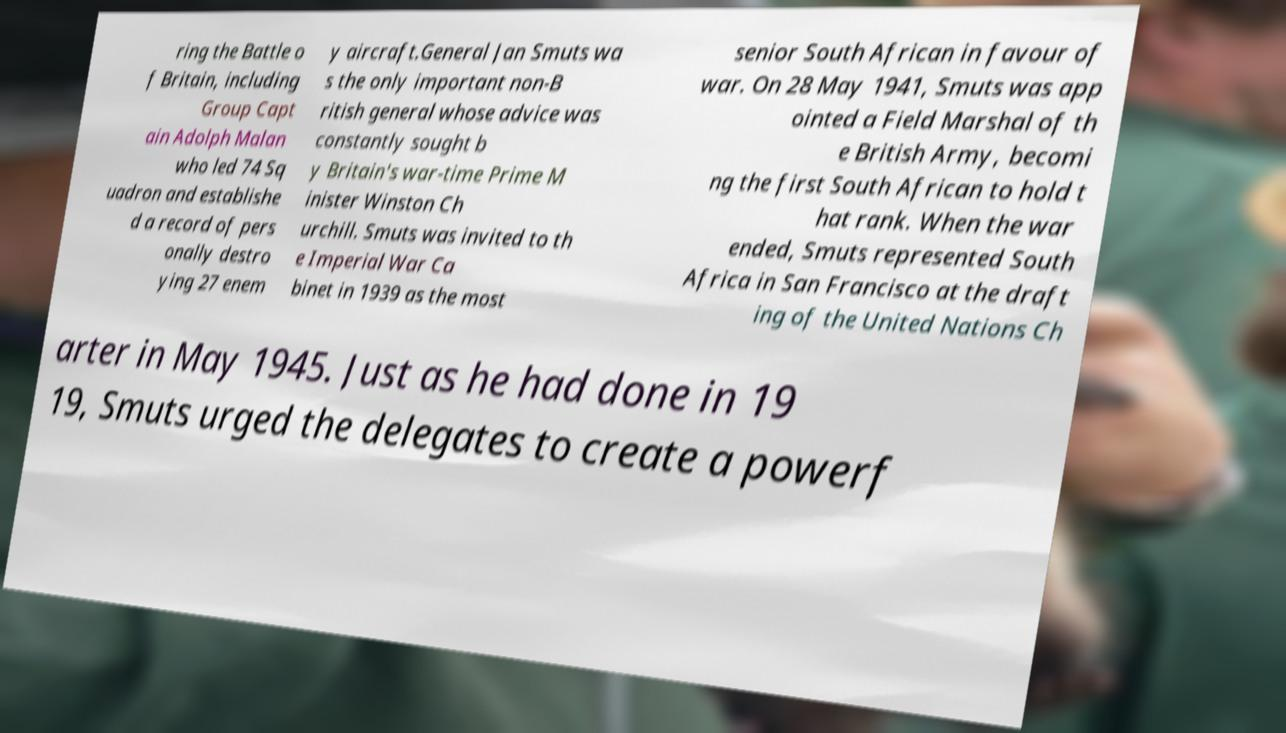Can you read and provide the text displayed in the image?This photo seems to have some interesting text. Can you extract and type it out for me? ring the Battle o f Britain, including Group Capt ain Adolph Malan who led 74 Sq uadron and establishe d a record of pers onally destro ying 27 enem y aircraft.General Jan Smuts wa s the only important non-B ritish general whose advice was constantly sought b y Britain's war-time Prime M inister Winston Ch urchill. Smuts was invited to th e Imperial War Ca binet in 1939 as the most senior South African in favour of war. On 28 May 1941, Smuts was app ointed a Field Marshal of th e British Army, becomi ng the first South African to hold t hat rank. When the war ended, Smuts represented South Africa in San Francisco at the draft ing of the United Nations Ch arter in May 1945. Just as he had done in 19 19, Smuts urged the delegates to create a powerf 